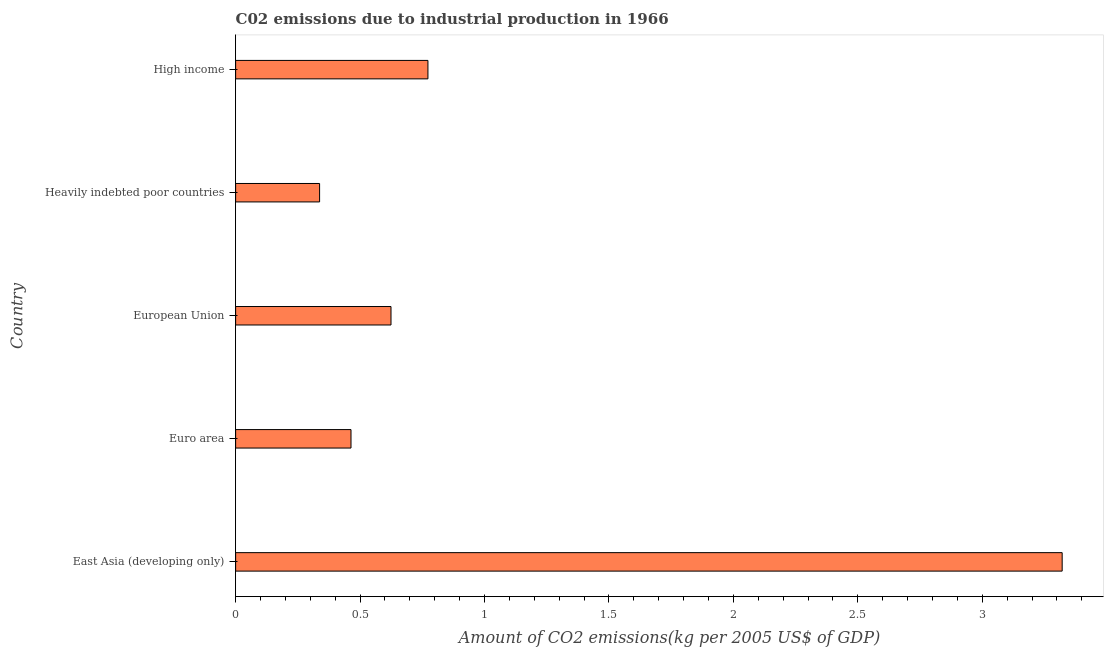Does the graph contain any zero values?
Your answer should be compact. No. Does the graph contain grids?
Make the answer very short. No. What is the title of the graph?
Your answer should be very brief. C02 emissions due to industrial production in 1966. What is the label or title of the X-axis?
Your answer should be compact. Amount of CO2 emissions(kg per 2005 US$ of GDP). What is the amount of co2 emissions in Heavily indebted poor countries?
Ensure brevity in your answer.  0.34. Across all countries, what is the maximum amount of co2 emissions?
Offer a very short reply. 3.32. Across all countries, what is the minimum amount of co2 emissions?
Make the answer very short. 0.34. In which country was the amount of co2 emissions maximum?
Ensure brevity in your answer.  East Asia (developing only). In which country was the amount of co2 emissions minimum?
Your answer should be very brief. Heavily indebted poor countries. What is the sum of the amount of co2 emissions?
Give a very brief answer. 5.52. What is the difference between the amount of co2 emissions in Heavily indebted poor countries and High income?
Make the answer very short. -0.43. What is the average amount of co2 emissions per country?
Your answer should be compact. 1.1. What is the median amount of co2 emissions?
Offer a very short reply. 0.62. In how many countries, is the amount of co2 emissions greater than 1.4 kg per 2005 US$ of GDP?
Offer a very short reply. 1. What is the ratio of the amount of co2 emissions in European Union to that in High income?
Ensure brevity in your answer.  0.81. Is the amount of co2 emissions in European Union less than that in High income?
Make the answer very short. Yes. Is the difference between the amount of co2 emissions in European Union and High income greater than the difference between any two countries?
Your response must be concise. No. What is the difference between the highest and the second highest amount of co2 emissions?
Provide a succinct answer. 2.55. Is the sum of the amount of co2 emissions in Euro area and Heavily indebted poor countries greater than the maximum amount of co2 emissions across all countries?
Offer a very short reply. No. What is the difference between the highest and the lowest amount of co2 emissions?
Your response must be concise. 2.98. What is the difference between two consecutive major ticks on the X-axis?
Provide a succinct answer. 0.5. Are the values on the major ticks of X-axis written in scientific E-notation?
Provide a succinct answer. No. What is the Amount of CO2 emissions(kg per 2005 US$ of GDP) of East Asia (developing only)?
Give a very brief answer. 3.32. What is the Amount of CO2 emissions(kg per 2005 US$ of GDP) of Euro area?
Make the answer very short. 0.46. What is the Amount of CO2 emissions(kg per 2005 US$ of GDP) in European Union?
Your response must be concise. 0.62. What is the Amount of CO2 emissions(kg per 2005 US$ of GDP) of Heavily indebted poor countries?
Keep it short and to the point. 0.34. What is the Amount of CO2 emissions(kg per 2005 US$ of GDP) of High income?
Make the answer very short. 0.77. What is the difference between the Amount of CO2 emissions(kg per 2005 US$ of GDP) in East Asia (developing only) and Euro area?
Provide a succinct answer. 2.86. What is the difference between the Amount of CO2 emissions(kg per 2005 US$ of GDP) in East Asia (developing only) and European Union?
Offer a terse response. 2.7. What is the difference between the Amount of CO2 emissions(kg per 2005 US$ of GDP) in East Asia (developing only) and Heavily indebted poor countries?
Offer a very short reply. 2.98. What is the difference between the Amount of CO2 emissions(kg per 2005 US$ of GDP) in East Asia (developing only) and High income?
Offer a very short reply. 2.55. What is the difference between the Amount of CO2 emissions(kg per 2005 US$ of GDP) in Euro area and European Union?
Provide a succinct answer. -0.16. What is the difference between the Amount of CO2 emissions(kg per 2005 US$ of GDP) in Euro area and Heavily indebted poor countries?
Provide a short and direct response. 0.13. What is the difference between the Amount of CO2 emissions(kg per 2005 US$ of GDP) in Euro area and High income?
Give a very brief answer. -0.31. What is the difference between the Amount of CO2 emissions(kg per 2005 US$ of GDP) in European Union and Heavily indebted poor countries?
Ensure brevity in your answer.  0.29. What is the difference between the Amount of CO2 emissions(kg per 2005 US$ of GDP) in European Union and High income?
Your answer should be compact. -0.15. What is the difference between the Amount of CO2 emissions(kg per 2005 US$ of GDP) in Heavily indebted poor countries and High income?
Offer a very short reply. -0.44. What is the ratio of the Amount of CO2 emissions(kg per 2005 US$ of GDP) in East Asia (developing only) to that in Euro area?
Make the answer very short. 7.16. What is the ratio of the Amount of CO2 emissions(kg per 2005 US$ of GDP) in East Asia (developing only) to that in European Union?
Ensure brevity in your answer.  5.32. What is the ratio of the Amount of CO2 emissions(kg per 2005 US$ of GDP) in East Asia (developing only) to that in Heavily indebted poor countries?
Ensure brevity in your answer.  9.84. What is the ratio of the Amount of CO2 emissions(kg per 2005 US$ of GDP) in East Asia (developing only) to that in High income?
Give a very brief answer. 4.3. What is the ratio of the Amount of CO2 emissions(kg per 2005 US$ of GDP) in Euro area to that in European Union?
Ensure brevity in your answer.  0.74. What is the ratio of the Amount of CO2 emissions(kg per 2005 US$ of GDP) in Euro area to that in Heavily indebted poor countries?
Provide a short and direct response. 1.37. What is the ratio of the Amount of CO2 emissions(kg per 2005 US$ of GDP) in European Union to that in Heavily indebted poor countries?
Keep it short and to the point. 1.85. What is the ratio of the Amount of CO2 emissions(kg per 2005 US$ of GDP) in European Union to that in High income?
Your response must be concise. 0.81. What is the ratio of the Amount of CO2 emissions(kg per 2005 US$ of GDP) in Heavily indebted poor countries to that in High income?
Ensure brevity in your answer.  0.44. 